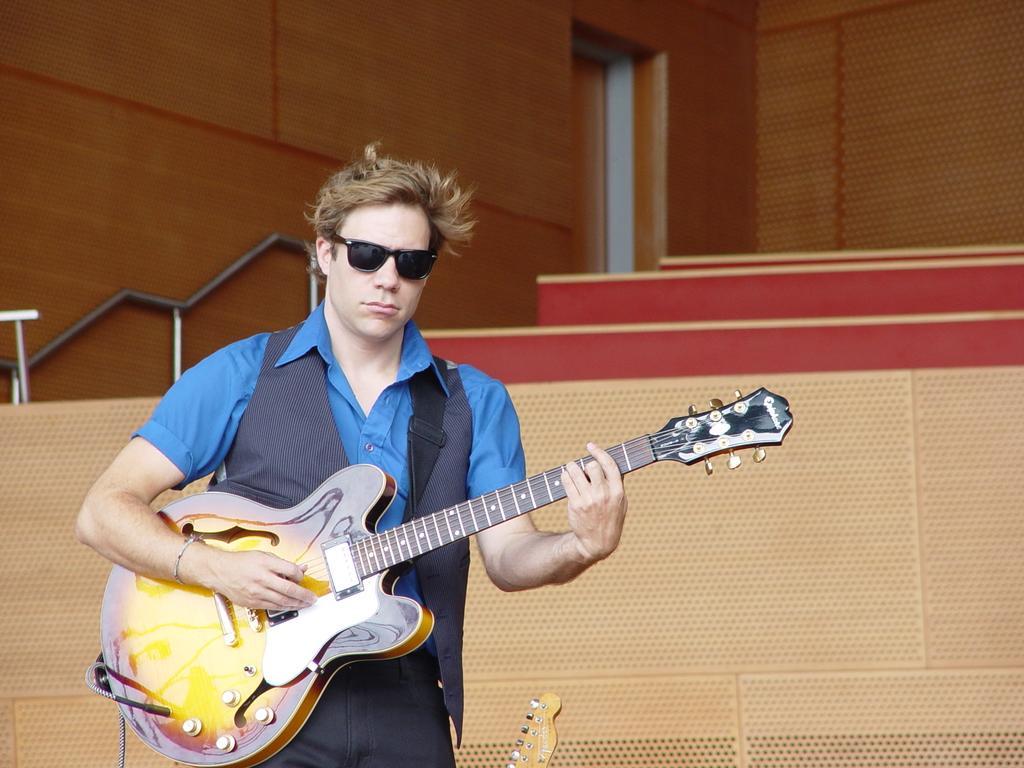Describe this image in one or two sentences. In this image I can see a person standing and holding a guitar. At the background we can see a wooden wall. 